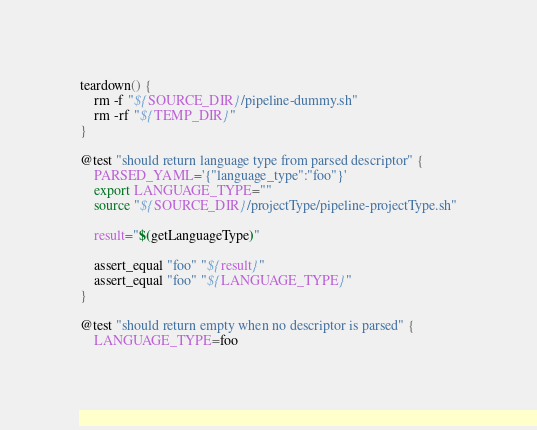<code> <loc_0><loc_0><loc_500><loc_500><_Bash_>teardown() {
	rm -f "${SOURCE_DIR}/pipeline-dummy.sh"
	rm -rf "${TEMP_DIR}"
}

@test "should return language type from parsed descriptor" {
	PARSED_YAML='{"language_type":"foo"}'
	export LANGUAGE_TYPE=""
	source "${SOURCE_DIR}/projectType/pipeline-projectType.sh"

	result="$(getLanguageType)"

	assert_equal "foo" "${result}"
	assert_equal "foo" "${LANGUAGE_TYPE}"
}

@test "should return empty when no descriptor is parsed" {
	LANGUAGE_TYPE=foo</code> 